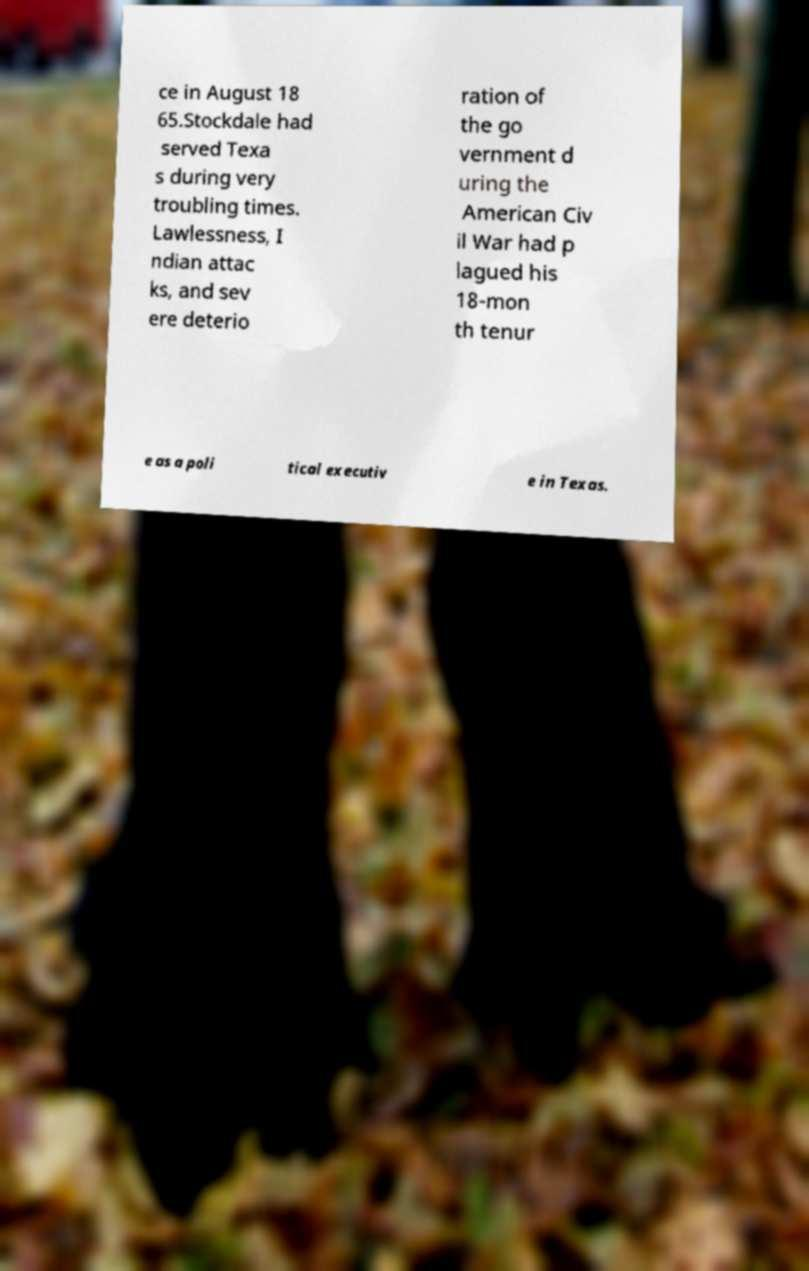Please identify and transcribe the text found in this image. ce in August 18 65.Stockdale had served Texa s during very troubling times. Lawlessness, I ndian attac ks, and sev ere deterio ration of the go vernment d uring the American Civ il War had p lagued his 18-mon th tenur e as a poli tical executiv e in Texas. 